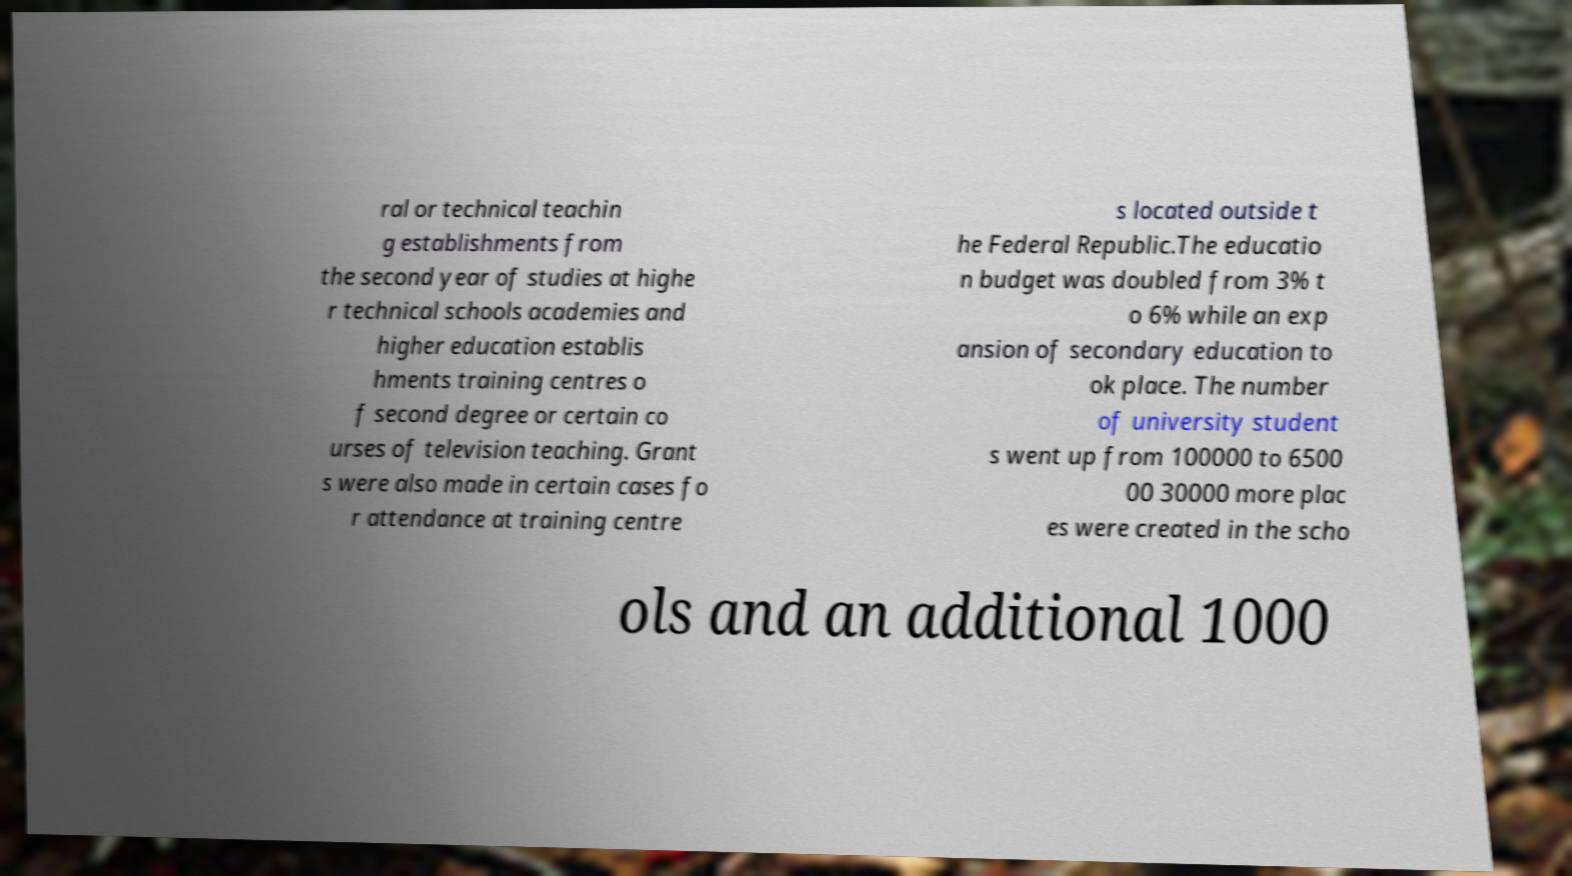Can you accurately transcribe the text from the provided image for me? ral or technical teachin g establishments from the second year of studies at highe r technical schools academies and higher education establis hments training centres o f second degree or certain co urses of television teaching. Grant s were also made in certain cases fo r attendance at training centre s located outside t he Federal Republic.The educatio n budget was doubled from 3% t o 6% while an exp ansion of secondary education to ok place. The number of university student s went up from 100000 to 6500 00 30000 more plac es were created in the scho ols and an additional 1000 